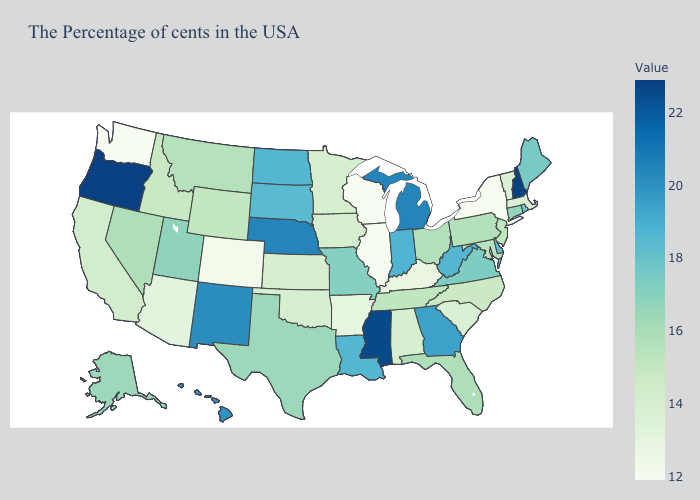Does Alaska have the lowest value in the West?
Quick response, please. No. Which states have the lowest value in the South?
Short answer required. Kentucky. Does Connecticut have the lowest value in the Northeast?
Concise answer only. No. Does Montana have a higher value than Rhode Island?
Quick response, please. No. Which states have the lowest value in the USA?
Give a very brief answer. New York, Wisconsin, Illinois, Washington. 